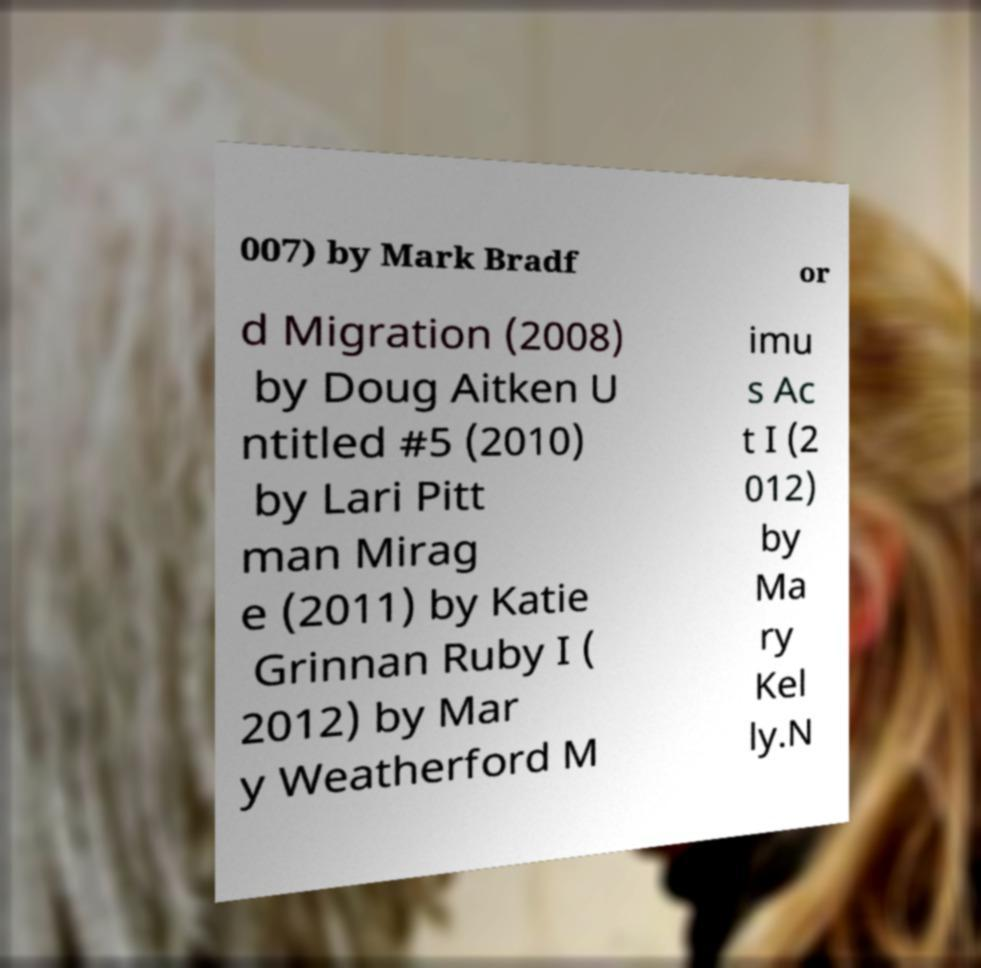Please identify and transcribe the text found in this image. 007) by Mark Bradf or d Migration (2008) by Doug Aitken U ntitled #5 (2010) by Lari Pitt man Mirag e (2011) by Katie Grinnan Ruby I ( 2012) by Mar y Weatherford M imu s Ac t I (2 012) by Ma ry Kel ly.N 